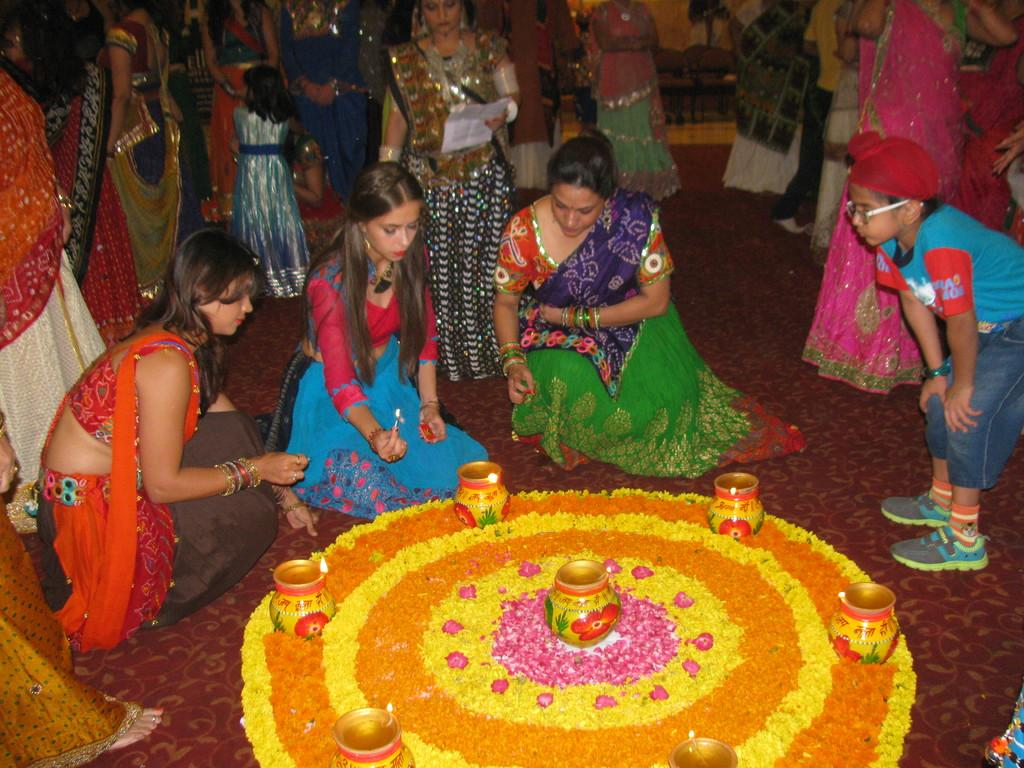Who or what can be seen in the image? There are people in the image. What else is present in the image besides people? There are flowers, pots, and other objects in the image. Can you describe the flowers in the image? The flowers are in pots in the image. What is one person doing in the image? One person is holding a paper. What type of yam is being used as a hobby in the image? There is no yam present in the image, and no hobbies are depicted. 